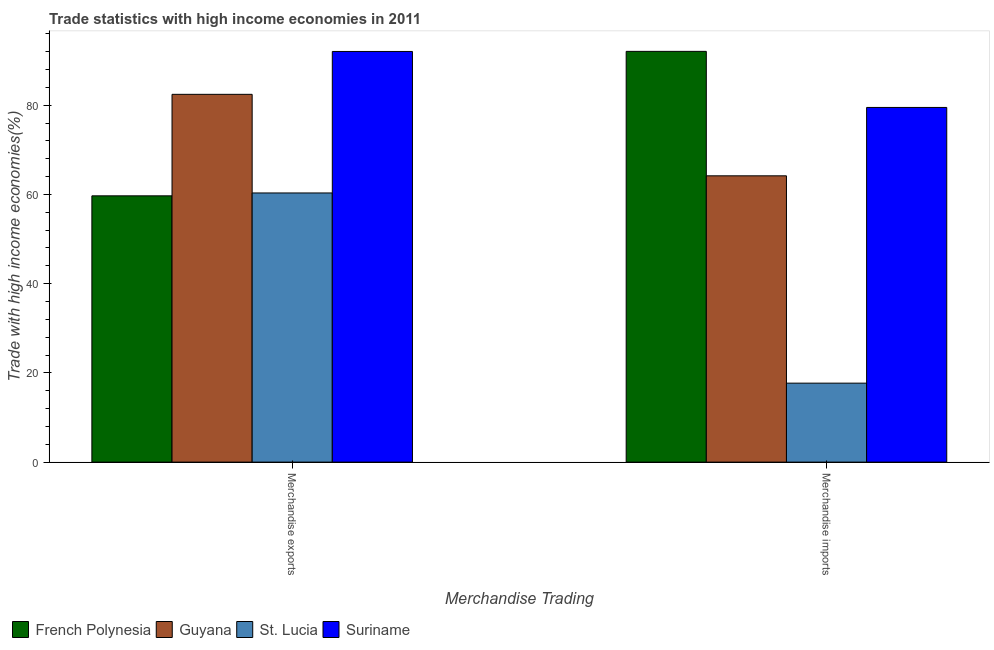How many different coloured bars are there?
Make the answer very short. 4. How many groups of bars are there?
Your answer should be compact. 2. Are the number of bars on each tick of the X-axis equal?
Offer a very short reply. Yes. What is the merchandise imports in St. Lucia?
Ensure brevity in your answer.  17.7. Across all countries, what is the maximum merchandise exports?
Offer a very short reply. 92.04. Across all countries, what is the minimum merchandise imports?
Give a very brief answer. 17.7. In which country was the merchandise imports maximum?
Your answer should be compact. French Polynesia. In which country was the merchandise exports minimum?
Ensure brevity in your answer.  French Polynesia. What is the total merchandise exports in the graph?
Make the answer very short. 294.49. What is the difference between the merchandise exports in St. Lucia and that in French Polynesia?
Give a very brief answer. 0.65. What is the difference between the merchandise exports in Guyana and the merchandise imports in French Polynesia?
Keep it short and to the point. -9.63. What is the average merchandise imports per country?
Provide a succinct answer. 63.36. What is the difference between the merchandise imports and merchandise exports in French Polynesia?
Provide a short and direct response. 32.38. What is the ratio of the merchandise exports in Suriname to that in St. Lucia?
Make the answer very short. 1.53. Is the merchandise exports in St. Lucia less than that in Suriname?
Offer a terse response. Yes. What does the 4th bar from the left in Merchandise exports represents?
Your answer should be compact. Suriname. What does the 3rd bar from the right in Merchandise imports represents?
Give a very brief answer. Guyana. Are all the bars in the graph horizontal?
Provide a short and direct response. No. What is the difference between two consecutive major ticks on the Y-axis?
Offer a terse response. 20. Does the graph contain grids?
Provide a succinct answer. No. How many legend labels are there?
Offer a very short reply. 4. What is the title of the graph?
Offer a terse response. Trade statistics with high income economies in 2011. What is the label or title of the X-axis?
Your response must be concise. Merchandise Trading. What is the label or title of the Y-axis?
Offer a very short reply. Trade with high income economies(%). What is the Trade with high income economies(%) of French Polynesia in Merchandise exports?
Offer a very short reply. 59.68. What is the Trade with high income economies(%) in Guyana in Merchandise exports?
Your answer should be very brief. 82.43. What is the Trade with high income economies(%) in St. Lucia in Merchandise exports?
Give a very brief answer. 60.33. What is the Trade with high income economies(%) in Suriname in Merchandise exports?
Provide a succinct answer. 92.04. What is the Trade with high income economies(%) of French Polynesia in Merchandise imports?
Keep it short and to the point. 92.06. What is the Trade with high income economies(%) of Guyana in Merchandise imports?
Offer a terse response. 64.17. What is the Trade with high income economies(%) of St. Lucia in Merchandise imports?
Provide a succinct answer. 17.7. What is the Trade with high income economies(%) in Suriname in Merchandise imports?
Offer a terse response. 79.49. Across all Merchandise Trading, what is the maximum Trade with high income economies(%) of French Polynesia?
Make the answer very short. 92.06. Across all Merchandise Trading, what is the maximum Trade with high income economies(%) of Guyana?
Provide a succinct answer. 82.43. Across all Merchandise Trading, what is the maximum Trade with high income economies(%) of St. Lucia?
Your answer should be very brief. 60.33. Across all Merchandise Trading, what is the maximum Trade with high income economies(%) in Suriname?
Make the answer very short. 92.04. Across all Merchandise Trading, what is the minimum Trade with high income economies(%) in French Polynesia?
Your answer should be very brief. 59.68. Across all Merchandise Trading, what is the minimum Trade with high income economies(%) in Guyana?
Give a very brief answer. 64.17. Across all Merchandise Trading, what is the minimum Trade with high income economies(%) of St. Lucia?
Your answer should be compact. 17.7. Across all Merchandise Trading, what is the minimum Trade with high income economies(%) of Suriname?
Give a very brief answer. 79.49. What is the total Trade with high income economies(%) of French Polynesia in the graph?
Provide a succinct answer. 151.75. What is the total Trade with high income economies(%) of Guyana in the graph?
Your response must be concise. 146.6. What is the total Trade with high income economies(%) of St. Lucia in the graph?
Provide a short and direct response. 78.03. What is the total Trade with high income economies(%) in Suriname in the graph?
Your answer should be very brief. 171.54. What is the difference between the Trade with high income economies(%) of French Polynesia in Merchandise exports and that in Merchandise imports?
Provide a short and direct response. -32.38. What is the difference between the Trade with high income economies(%) of Guyana in Merchandise exports and that in Merchandise imports?
Offer a terse response. 18.26. What is the difference between the Trade with high income economies(%) in St. Lucia in Merchandise exports and that in Merchandise imports?
Provide a succinct answer. 42.63. What is the difference between the Trade with high income economies(%) in Suriname in Merchandise exports and that in Merchandise imports?
Your answer should be compact. 12.55. What is the difference between the Trade with high income economies(%) in French Polynesia in Merchandise exports and the Trade with high income economies(%) in Guyana in Merchandise imports?
Offer a very short reply. -4.48. What is the difference between the Trade with high income economies(%) in French Polynesia in Merchandise exports and the Trade with high income economies(%) in St. Lucia in Merchandise imports?
Provide a succinct answer. 41.98. What is the difference between the Trade with high income economies(%) in French Polynesia in Merchandise exports and the Trade with high income economies(%) in Suriname in Merchandise imports?
Your answer should be very brief. -19.81. What is the difference between the Trade with high income economies(%) in Guyana in Merchandise exports and the Trade with high income economies(%) in St. Lucia in Merchandise imports?
Give a very brief answer. 64.73. What is the difference between the Trade with high income economies(%) of Guyana in Merchandise exports and the Trade with high income economies(%) of Suriname in Merchandise imports?
Provide a short and direct response. 2.94. What is the difference between the Trade with high income economies(%) of St. Lucia in Merchandise exports and the Trade with high income economies(%) of Suriname in Merchandise imports?
Provide a short and direct response. -19.17. What is the average Trade with high income economies(%) of French Polynesia per Merchandise Trading?
Make the answer very short. 75.87. What is the average Trade with high income economies(%) of Guyana per Merchandise Trading?
Your answer should be compact. 73.3. What is the average Trade with high income economies(%) of St. Lucia per Merchandise Trading?
Make the answer very short. 39.01. What is the average Trade with high income economies(%) in Suriname per Merchandise Trading?
Provide a short and direct response. 85.77. What is the difference between the Trade with high income economies(%) of French Polynesia and Trade with high income economies(%) of Guyana in Merchandise exports?
Provide a succinct answer. -22.75. What is the difference between the Trade with high income economies(%) in French Polynesia and Trade with high income economies(%) in St. Lucia in Merchandise exports?
Offer a terse response. -0.65. What is the difference between the Trade with high income economies(%) of French Polynesia and Trade with high income economies(%) of Suriname in Merchandise exports?
Offer a very short reply. -32.36. What is the difference between the Trade with high income economies(%) in Guyana and Trade with high income economies(%) in St. Lucia in Merchandise exports?
Give a very brief answer. 22.1. What is the difference between the Trade with high income economies(%) of Guyana and Trade with high income economies(%) of Suriname in Merchandise exports?
Your response must be concise. -9.61. What is the difference between the Trade with high income economies(%) in St. Lucia and Trade with high income economies(%) in Suriname in Merchandise exports?
Your response must be concise. -31.71. What is the difference between the Trade with high income economies(%) in French Polynesia and Trade with high income economies(%) in Guyana in Merchandise imports?
Your answer should be very brief. 27.9. What is the difference between the Trade with high income economies(%) of French Polynesia and Trade with high income economies(%) of St. Lucia in Merchandise imports?
Provide a succinct answer. 74.36. What is the difference between the Trade with high income economies(%) in French Polynesia and Trade with high income economies(%) in Suriname in Merchandise imports?
Provide a short and direct response. 12.57. What is the difference between the Trade with high income economies(%) of Guyana and Trade with high income economies(%) of St. Lucia in Merchandise imports?
Offer a very short reply. 46.47. What is the difference between the Trade with high income economies(%) in Guyana and Trade with high income economies(%) in Suriname in Merchandise imports?
Ensure brevity in your answer.  -15.33. What is the difference between the Trade with high income economies(%) in St. Lucia and Trade with high income economies(%) in Suriname in Merchandise imports?
Your answer should be compact. -61.8. What is the ratio of the Trade with high income economies(%) in French Polynesia in Merchandise exports to that in Merchandise imports?
Give a very brief answer. 0.65. What is the ratio of the Trade with high income economies(%) in Guyana in Merchandise exports to that in Merchandise imports?
Your response must be concise. 1.28. What is the ratio of the Trade with high income economies(%) in St. Lucia in Merchandise exports to that in Merchandise imports?
Your answer should be very brief. 3.41. What is the ratio of the Trade with high income economies(%) in Suriname in Merchandise exports to that in Merchandise imports?
Provide a succinct answer. 1.16. What is the difference between the highest and the second highest Trade with high income economies(%) of French Polynesia?
Your response must be concise. 32.38. What is the difference between the highest and the second highest Trade with high income economies(%) in Guyana?
Provide a succinct answer. 18.26. What is the difference between the highest and the second highest Trade with high income economies(%) in St. Lucia?
Your response must be concise. 42.63. What is the difference between the highest and the second highest Trade with high income economies(%) of Suriname?
Make the answer very short. 12.55. What is the difference between the highest and the lowest Trade with high income economies(%) of French Polynesia?
Offer a very short reply. 32.38. What is the difference between the highest and the lowest Trade with high income economies(%) in Guyana?
Give a very brief answer. 18.26. What is the difference between the highest and the lowest Trade with high income economies(%) of St. Lucia?
Your response must be concise. 42.63. What is the difference between the highest and the lowest Trade with high income economies(%) in Suriname?
Keep it short and to the point. 12.55. 